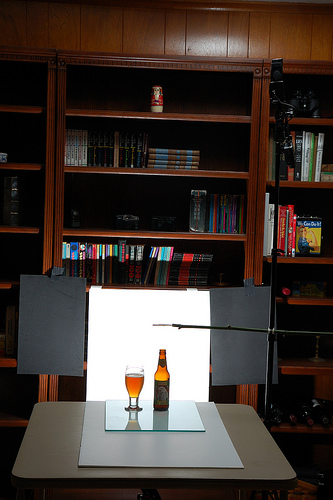<image>
Can you confirm if the wine is on the table? Yes. Looking at the image, I can see the wine is positioned on top of the table, with the table providing support. Is there a bottle on the glass? No. The bottle is not positioned on the glass. They may be near each other, but the bottle is not supported by or resting on top of the glass. 